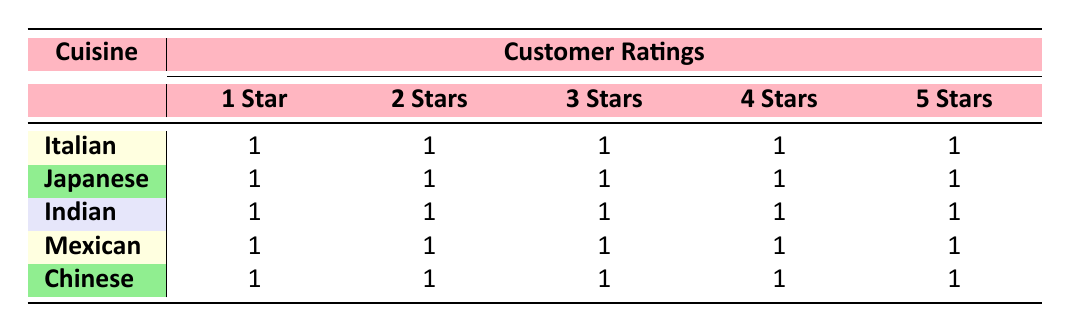What is the total number of 5-star reviews across all cuisines? Each cuisine has exactly one 5-star review listed in the table. There are five cuisines: Italian, Japanese, Indian, Mexican, and Chinese. Therefore, the total is 5 (from each cuisine).
Answer: 5 Which cuisine received the highest number of 2-star reviews? Each cuisine has exactly one 2-star review listed in the table. Since all cuisines have the same amount, there is no single cuisine with the highest number.
Answer: None Does the Italian cuisine have more 5-star than 1-star reviews? The Italian cuisine has one 5-star review and one 1-star review as indicated in the table. Since they are equal, the statement is false.
Answer: No What is the total number of 3-star reviews for all cuisines combined? Each cuisine has one 3-star review, and there are five cuisines in total. Thus, summing them gives a total of 5 (one from each cuisine).
Answer: 5 Is the total number of 1-star reviews equal to the total number of 4-star reviews? Each cuisine has one 1-star and one 4-star review. Since there are five cuisines, the total number for both ratings is 5. Therefore, yes, they are equal.
Answer: Yes What is the difference between the total number of 4-star reviews and 2-star reviews for all cuisines? Each cuisine has one review for both ratings, leading to a total of 5 for each. The difference is 5 (4-star) - 5 (2-star) = 0.
Answer: 0 Which cuisine type has a higher overall review rating, Italian or Japanese? Both Italian and Japanese cuisines have the same distribution of reviews; each has 5 ratings of a different score (1 through 5). Therefore, neither cuisine is higher overall, as they are equal.
Answer: None What is the sum of all 1-star and 5-star reviews across all cuisines? There are a total of 5 one-star reviews and 5 five-star reviews across all five cuisines. Adding these gives 5 (1-star) + 5 (5-star) = 10.
Answer: 10 